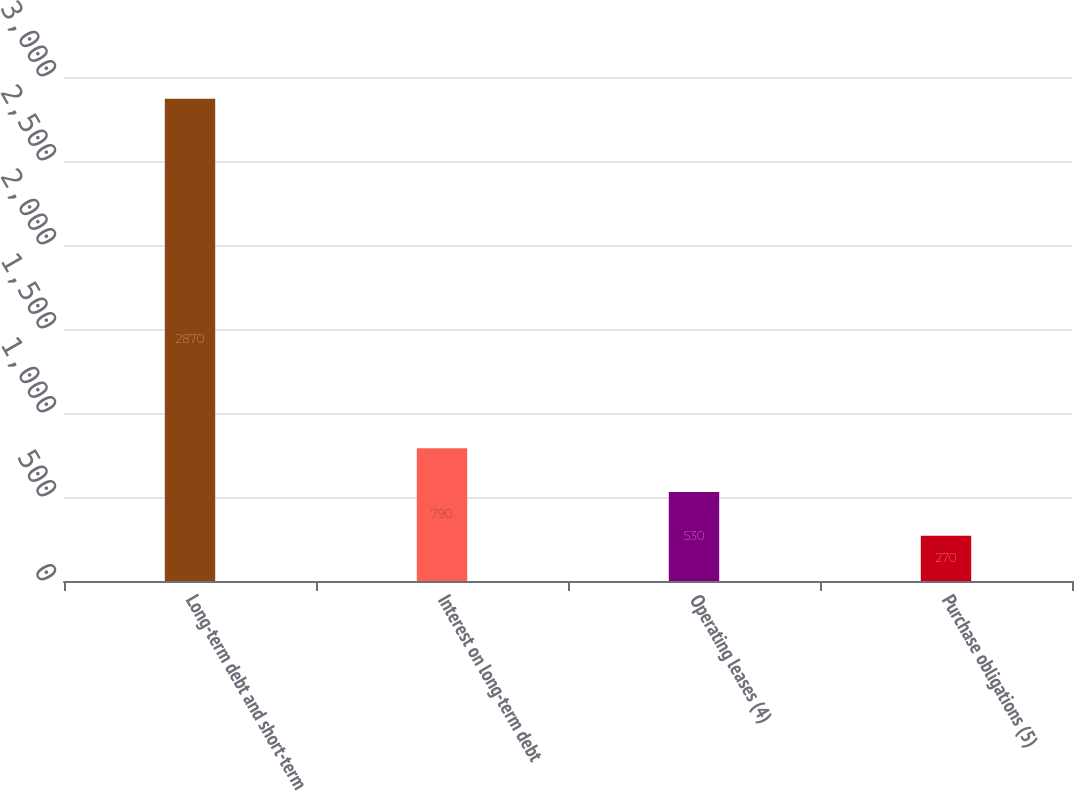Convert chart to OTSL. <chart><loc_0><loc_0><loc_500><loc_500><bar_chart><fcel>Long-term debt and short-term<fcel>Interest on long-term debt<fcel>Operating leases (4)<fcel>Purchase obligations (5)<nl><fcel>2870<fcel>790<fcel>530<fcel>270<nl></chart> 